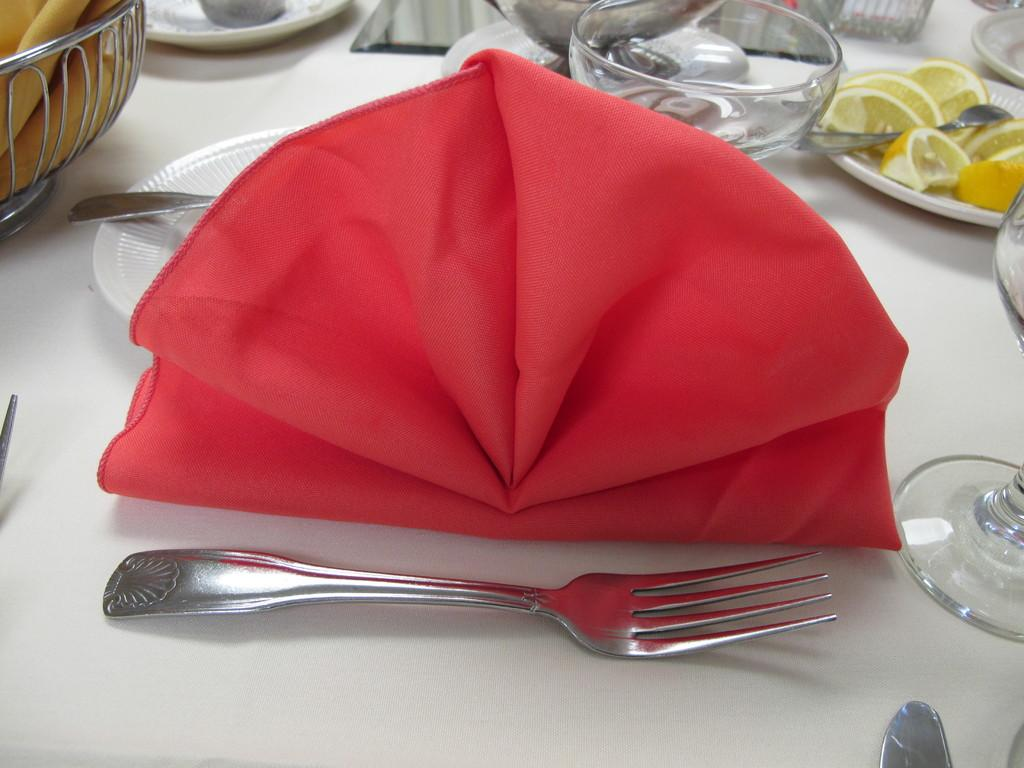What is the primary color of the surface in the image? The primary color of the surface in the image is white. What utensil can be seen on the white surface? There is a fork on the white surface. What item is used for wiping or cleaning in the image? There is a napkin on the white surface. What type of dishware is present on the white surface? There is a plate and a bowl on the white surface. What food item is visible on the plate with lemon pieces? There are lemon pieces on the plate with lemon pieces. What other utensil is present on the white surface? There is a spoon on the white surface. Can you describe any other items visible on the white surface? There are a few other items visible on the white surface, but their specific details are not mentioned in the provided facts. How many children are playing with the uncle in the image? There are no children or uncles present in the image; it features a white surface with various items on it. 